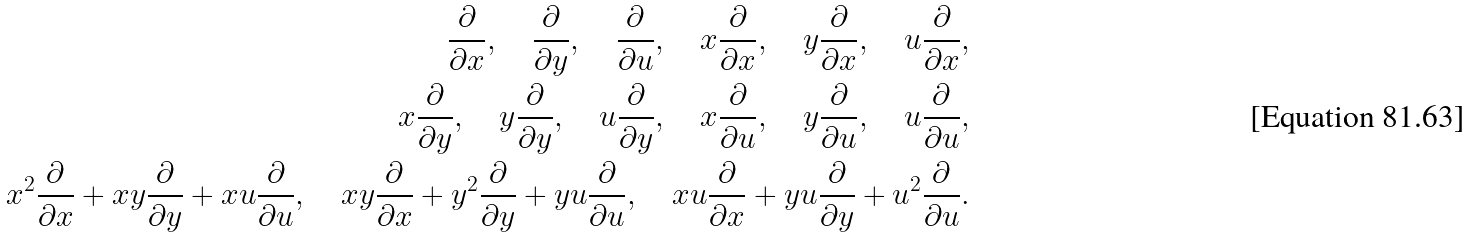Convert formula to latex. <formula><loc_0><loc_0><loc_500><loc_500>\frac { \partial } { \partial x } , \quad \frac { \partial } { \partial y } , \quad \frac { \partial } { \partial u } , \quad x \frac { \partial } { \partial x } , \quad y \frac { \partial } { \partial x } , \quad u \frac { \partial } { \partial x } , \\ x \frac { \partial } { \partial y } , \quad y \frac { \partial } { \partial y } , \quad u \frac { \partial } { \partial y } , \quad x \frac { \partial } { \partial u } , \quad y \frac { \partial } { \partial u } , \quad u \frac { \partial } { \partial u } , \\ x ^ { 2 } \frac { \partial } { \partial x } + x y \frac { \partial } { \partial y } + x u \frac { \partial } { \partial u } , \quad x y \frac { \partial } { \partial x } + y ^ { 2 } \frac { \partial } { \partial y } + y u \frac { \partial } { \partial u } , \quad x u \frac { \partial } { \partial x } + y u \frac { \partial } { \partial y } + u ^ { 2 } \frac { \partial } { \partial u } .</formula> 